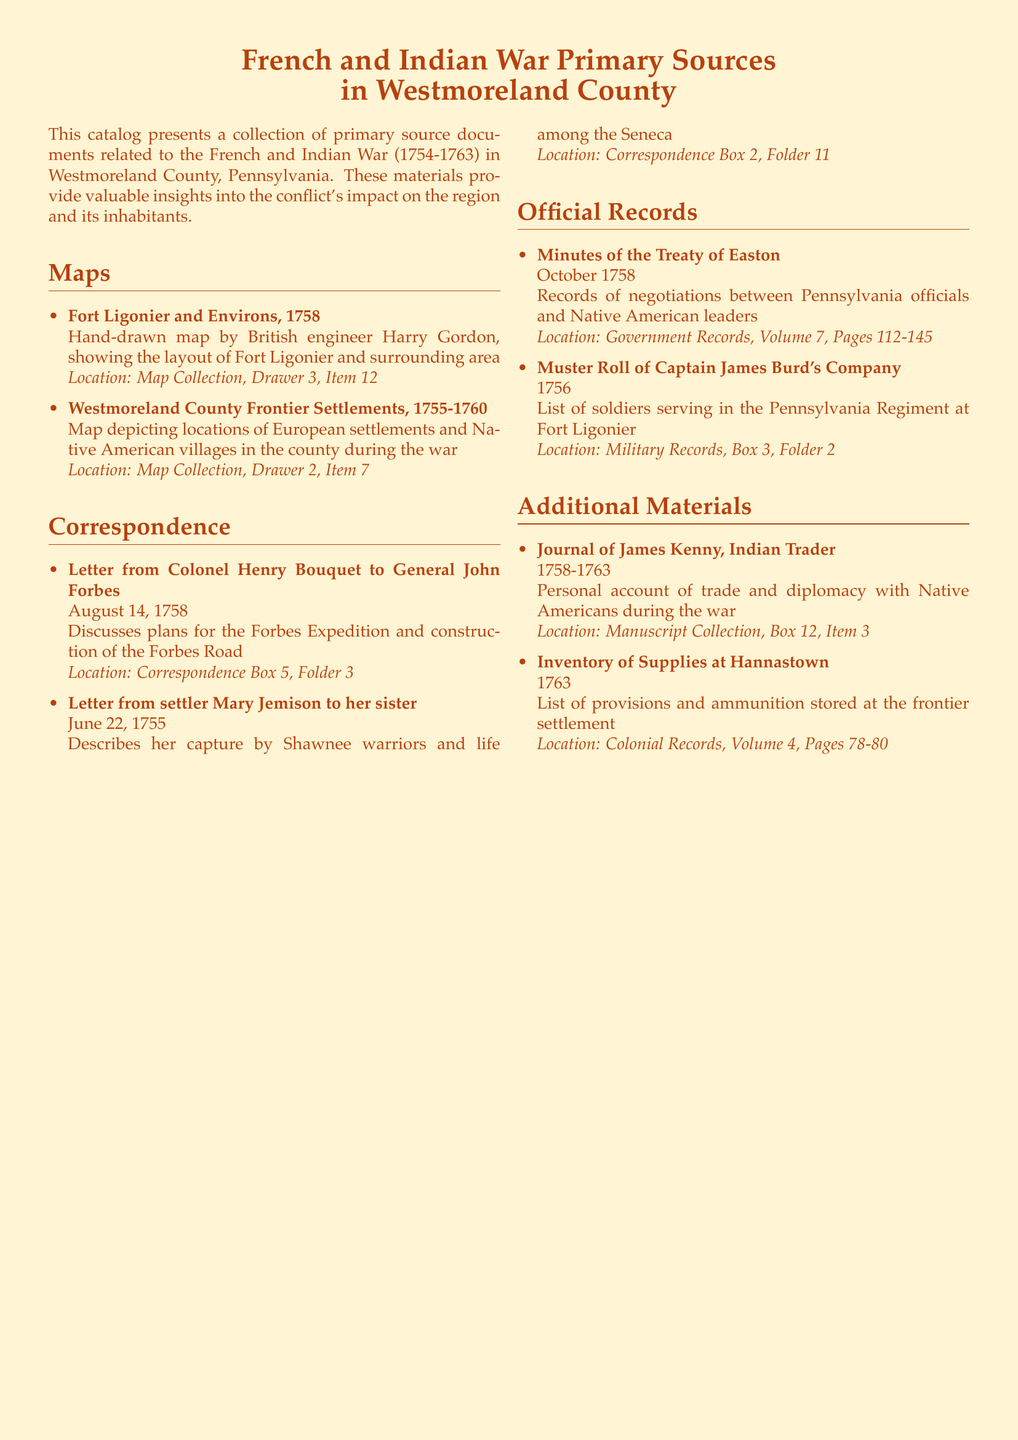What is the title of the first map listed? The first map listed is titled "Fort Ligonier and Environs, 1758."
Answer: Fort Ligonier and Environs, 1758 Who wrote the letter to General John Forbes? The letter to General John Forbes was written by Colonel Henry Bouquet.
Answer: Colonel Henry Bouquet What year does the Muster Roll of Captain James Burd's Company pertain to? The Muster Roll pertains to the year 1756.
Answer: 1756 How many items are listed under Correspondence? There are two items listed under Correspondence.
Answer: 2 What is the date of the letter from Mary Jemison? The letter from Mary Jemison is dated June 22, 1755.
Answer: June 22, 1755 Which document includes records of negotiations between Pennsylvania officials and Native American leaders? The document is titled "Minutes of the Treaty of Easton."
Answer: Minutes of the Treaty of Easton Where can the Journal of James Kenny be found? It can be found in the "Manuscript Collection, Box 12, Item 3."
Answer: Manuscript Collection, Box 12, Item 3 What type of materials are included in the catalog? The catalog includes maps, letters, and official records.
Answer: maps, letters, and official records What is the subtitle of the catalog? The subtitle is "in Westmoreland County."
Answer: in Westmoreland County 